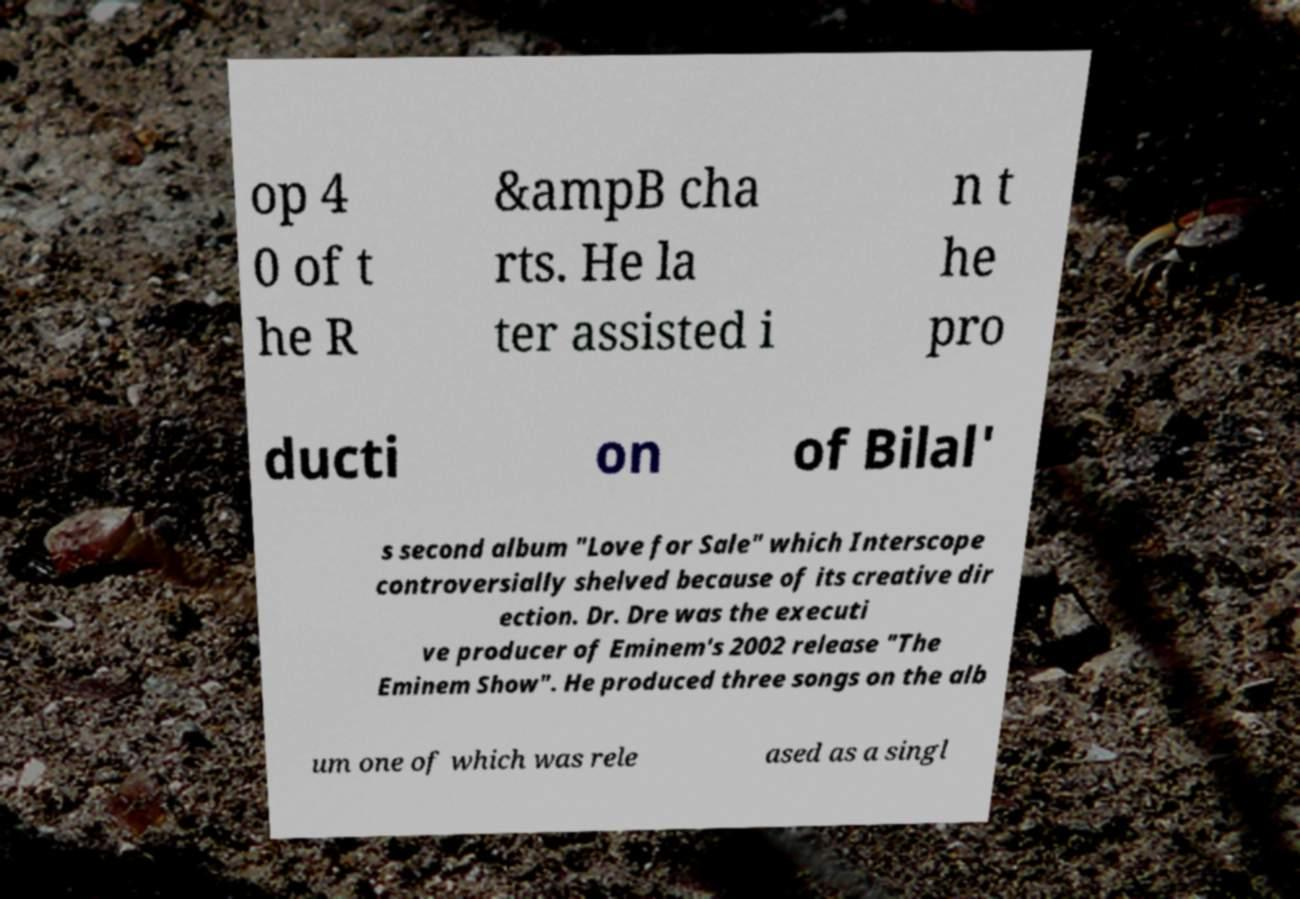Can you accurately transcribe the text from the provided image for me? op 4 0 of t he R &ampB cha rts. He la ter assisted i n t he pro ducti on of Bilal' s second album "Love for Sale" which Interscope controversially shelved because of its creative dir ection. Dr. Dre was the executi ve producer of Eminem's 2002 release "The Eminem Show". He produced three songs on the alb um one of which was rele ased as a singl 